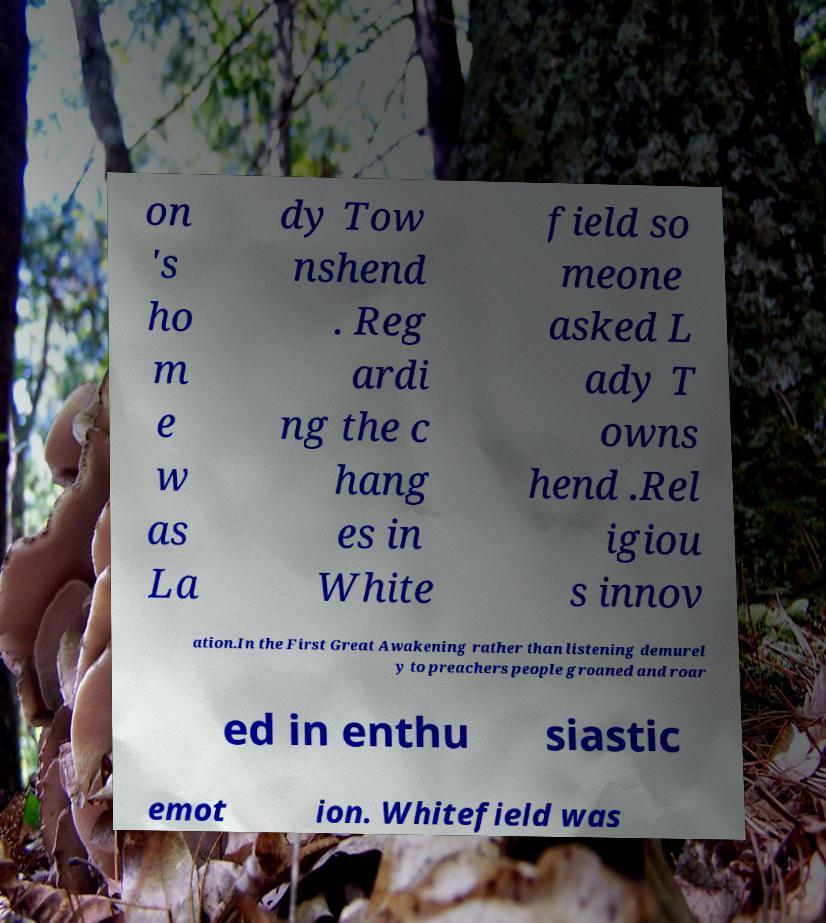Can you accurately transcribe the text from the provided image for me? on 's ho m e w as La dy Tow nshend . Reg ardi ng the c hang es in White field so meone asked L ady T owns hend .Rel igiou s innov ation.In the First Great Awakening rather than listening demurel y to preachers people groaned and roar ed in enthu siastic emot ion. Whitefield was 